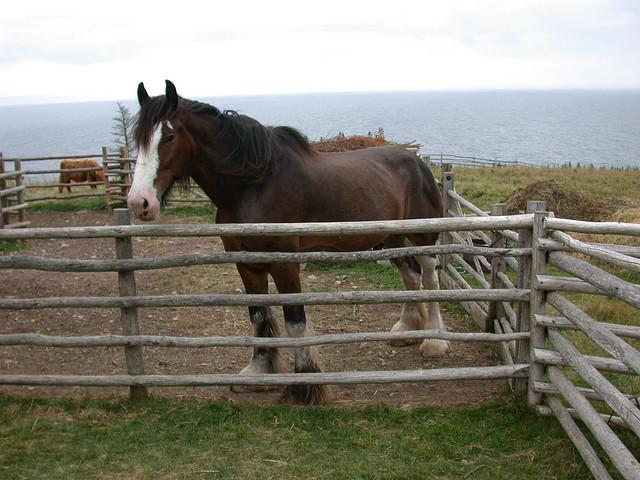What is the color of the horses hooves?
Short answer required. White. Is that water behind the horse?
Concise answer only. Yes. How many horses are in the photo?
Quick response, please. 1. 